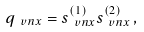Convert formula to latex. <formula><loc_0><loc_0><loc_500><loc_500>q _ { \ v n { x } } = s _ { \ v n { x } } ^ { ( 1 ) } s _ { \ v n { x } } ^ { ( 2 ) } \, ,</formula> 